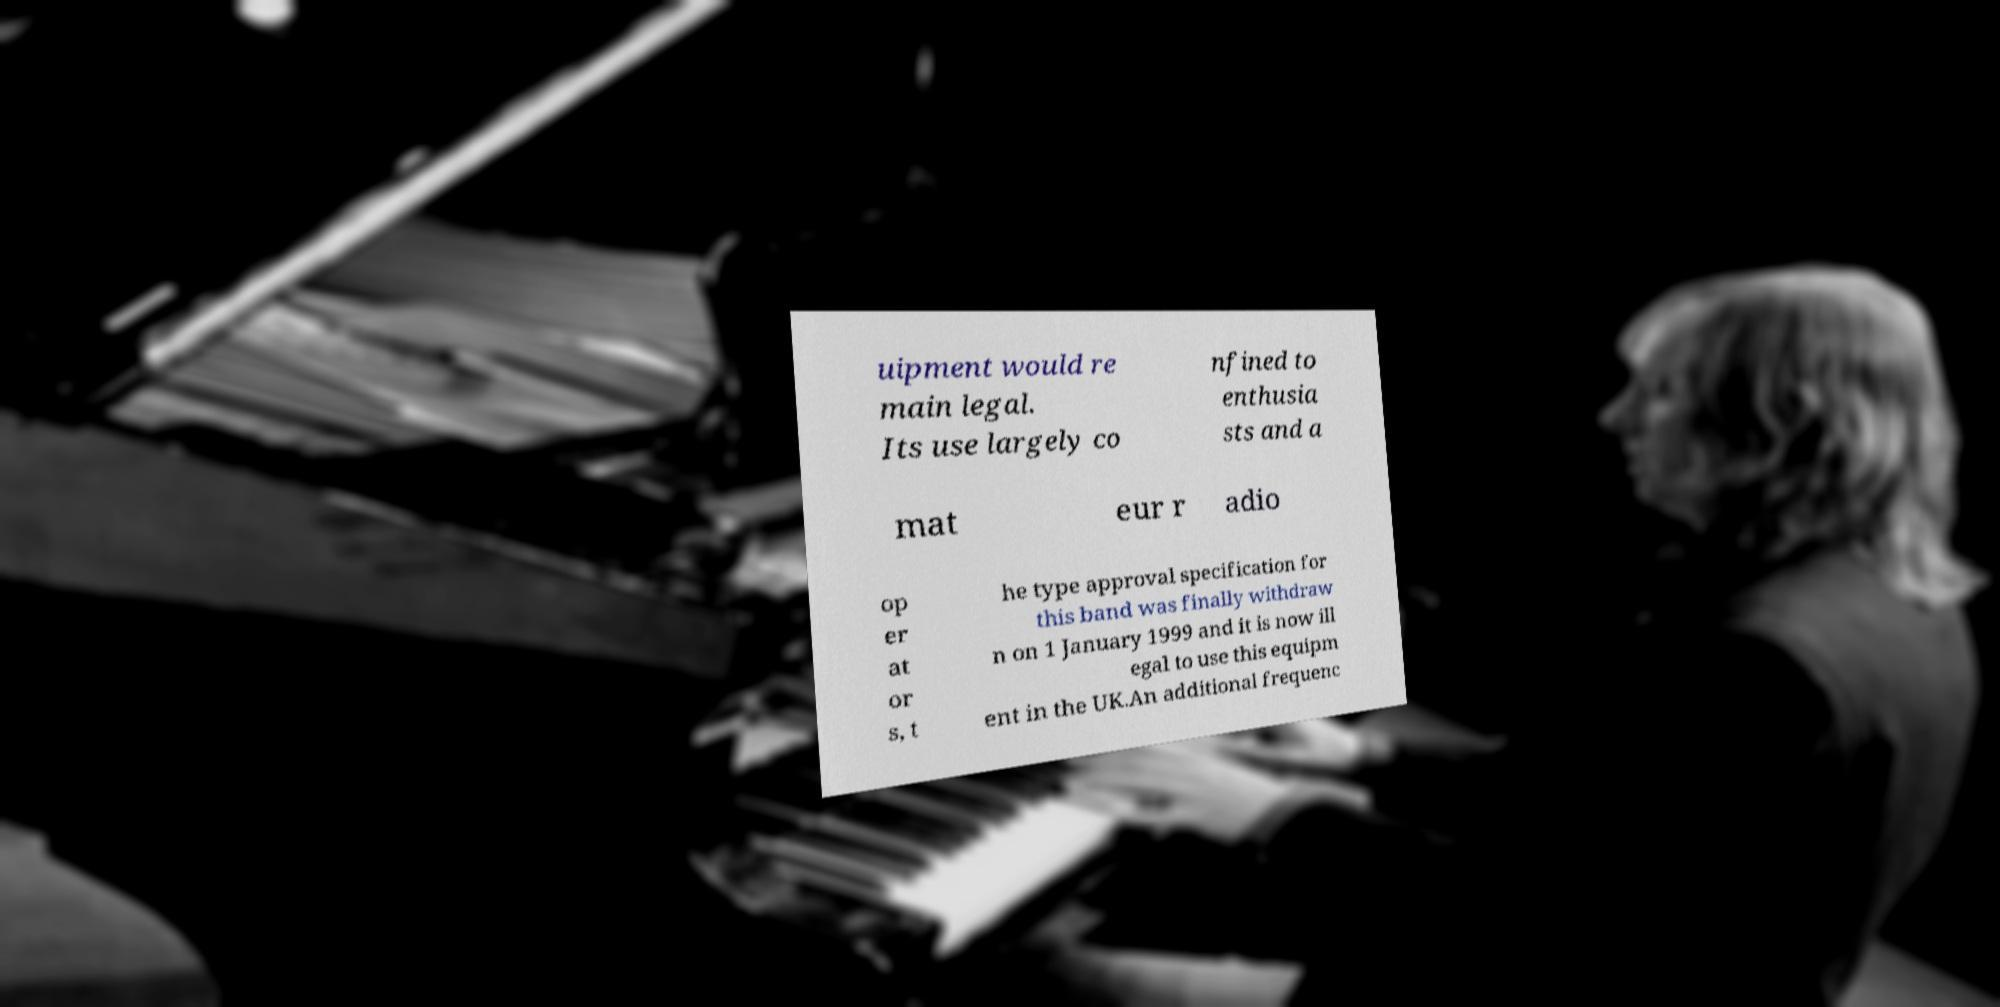Can you accurately transcribe the text from the provided image for me? uipment would re main legal. Its use largely co nfined to enthusia sts and a mat eur r adio op er at or s, t he type approval specification for this band was finally withdraw n on 1 January 1999 and it is now ill egal to use this equipm ent in the UK.An additional frequenc 